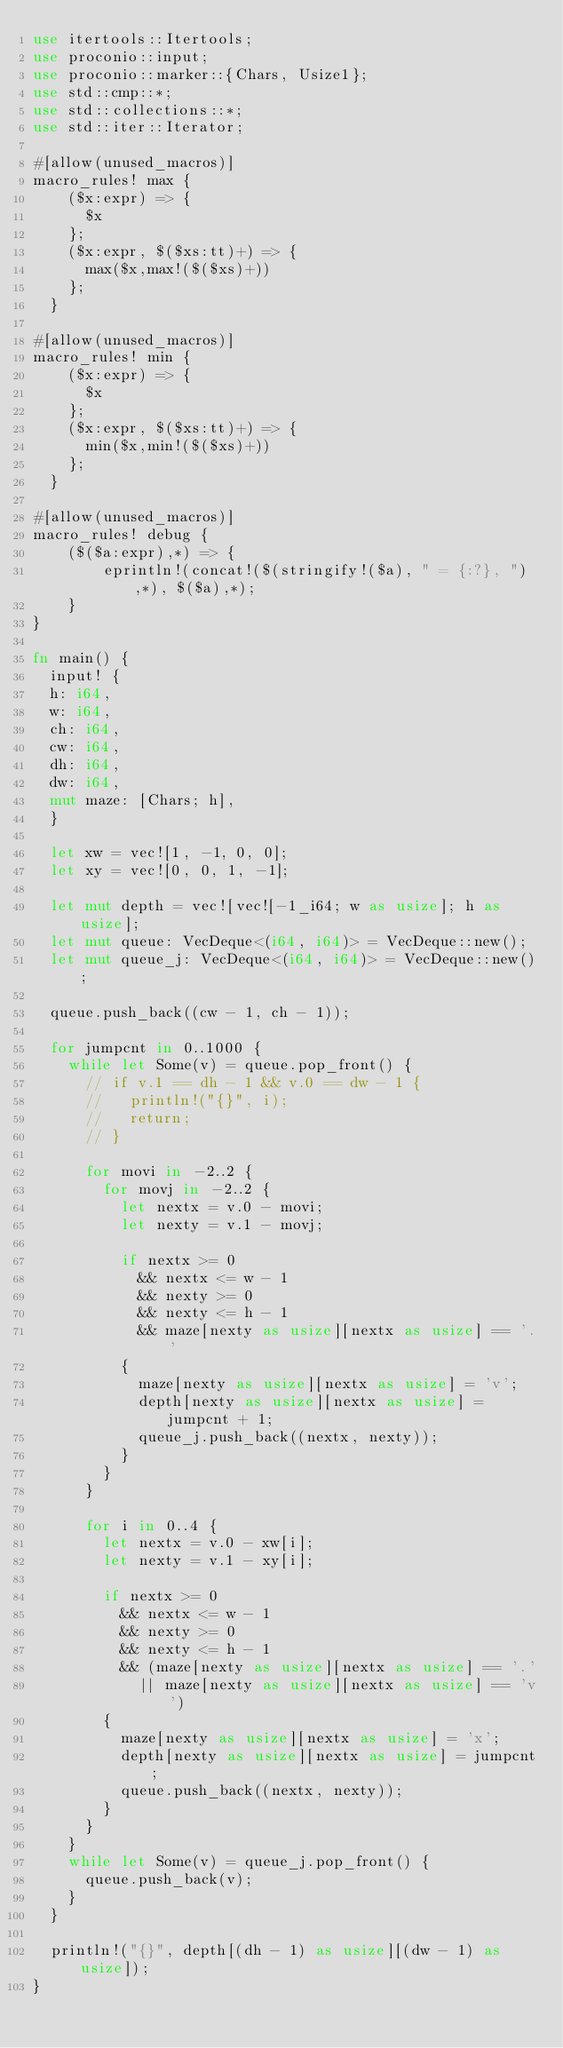Convert code to text. <code><loc_0><loc_0><loc_500><loc_500><_Rust_>use itertools::Itertools;
use proconio::input;
use proconio::marker::{Chars, Usize1};
use std::cmp::*;
use std::collections::*;
use std::iter::Iterator;

#[allow(unused_macros)]
macro_rules! max {
    ($x:expr) => {
      $x
    };
    ($x:expr, $($xs:tt)+) => {
      max($x,max!($($xs)+))
    };
  }

#[allow(unused_macros)]
macro_rules! min {
    ($x:expr) => {
      $x
    };
    ($x:expr, $($xs:tt)+) => {
      min($x,min!($($xs)+))
    };
  }

#[allow(unused_macros)]
macro_rules! debug {
    ($($a:expr),*) => {
        eprintln!(concat!($(stringify!($a), " = {:?}, "),*), $($a),*);
    }
}

fn main() {
  input! {
  h: i64,
  w: i64,
  ch: i64,
  cw: i64,
  dh: i64,
  dw: i64,
  mut maze: [Chars; h],
  }

  let xw = vec![1, -1, 0, 0];
  let xy = vec![0, 0, 1, -1];

  let mut depth = vec![vec![-1_i64; w as usize]; h as usize];
  let mut queue: VecDeque<(i64, i64)> = VecDeque::new();
  let mut queue_j: VecDeque<(i64, i64)> = VecDeque::new();

  queue.push_back((cw - 1, ch - 1));

  for jumpcnt in 0..1000 {
    while let Some(v) = queue.pop_front() {
      // if v.1 == dh - 1 && v.0 == dw - 1 {
      //   println!("{}", i);
      //   return;
      // }

      for movi in -2..2 {
        for movj in -2..2 {
          let nextx = v.0 - movi;
          let nexty = v.1 - movj;

          if nextx >= 0
            && nextx <= w - 1
            && nexty >= 0
            && nexty <= h - 1
            && maze[nexty as usize][nextx as usize] == '.'
          {
            maze[nexty as usize][nextx as usize] = 'v';
            depth[nexty as usize][nextx as usize] = jumpcnt + 1;
            queue_j.push_back((nextx, nexty));
          }
        }
      }

      for i in 0..4 {
        let nextx = v.0 - xw[i];
        let nexty = v.1 - xy[i];

        if nextx >= 0
          && nextx <= w - 1
          && nexty >= 0
          && nexty <= h - 1
          && (maze[nexty as usize][nextx as usize] == '.'
            || maze[nexty as usize][nextx as usize] == 'v')
        {
          maze[nexty as usize][nextx as usize] = 'x';
          depth[nexty as usize][nextx as usize] = jumpcnt;
          queue.push_back((nextx, nexty));
        }
      }
    }
    while let Some(v) = queue_j.pop_front() {
      queue.push_back(v);
    }
  }

  println!("{}", depth[(dh - 1) as usize][(dw - 1) as usize]);
}
</code> 